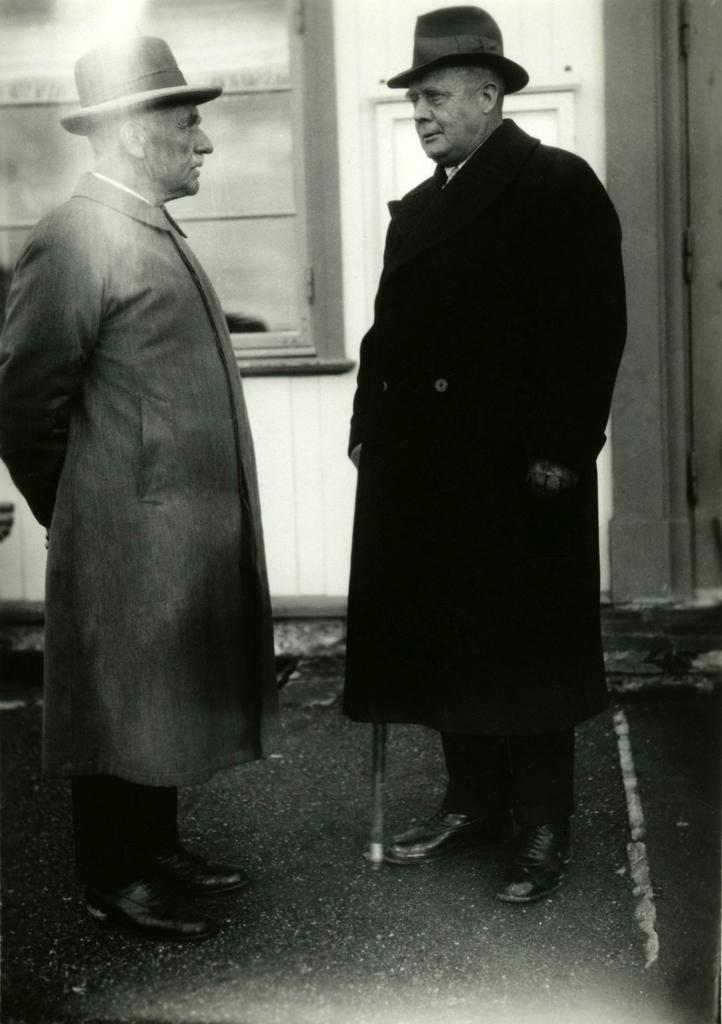Please provide a concise description of this image. This is a black and white picture. In this picture we can see two men standing, wearing hats and coats. In the background it seems like a window. At the bottom we can see the floor and a stick beside to a man. 